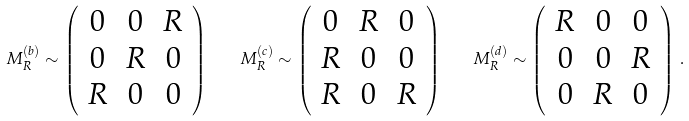Convert formula to latex. <formula><loc_0><loc_0><loc_500><loc_500>M _ { R } ^ { ( b ) } \sim \left ( \begin{array} { c c c } 0 & 0 & R \\ 0 & R & 0 \\ R & 0 & 0 \\ \end{array} \right ) \quad M _ { R } ^ { ( c ) } \sim \left ( \begin{array} { c c c } 0 & R & 0 \\ R & 0 & 0 \\ R & 0 & R \\ \end{array} \right ) \quad M _ { R } ^ { ( d ) } \sim \left ( \begin{array} { c c c } R & 0 & 0 \\ 0 & 0 & R \\ 0 & R & 0 \\ \end{array} \right ) \, .</formula> 